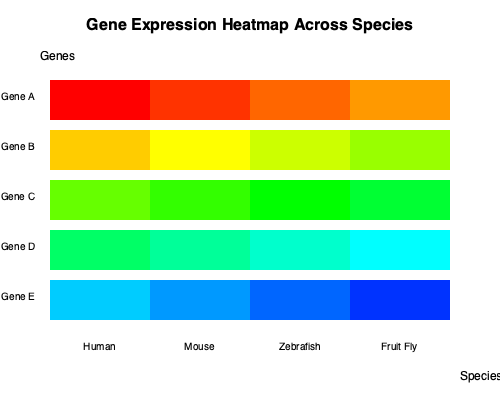Based on the gene expression heatmap across different species, which gene shows the highest degree of conservation in expression levels, and what does this suggest about its evolutionary importance? To determine the gene with the highest degree of conservation in expression levels, we need to analyze the heatmap row by row:

1. Gene A: Shows a gradient from red (high expression) in humans to orange (moderate expression) in fruit flies. This indicates variable expression across species.

2. Gene B: Displays yellow to light green colors across all species, suggesting relatively consistent moderate expression levels.

3. Gene C: Exhibits a consistent green color across all species, indicating highly conserved expression levels.

4. Gene D: Shows a gradient from light green to light blue, suggesting some variation in expression across species.

5. Gene E: Displays a gradient from light blue to dark blue, indicating variable expression across species.

Gene C shows the most consistent color (green) across all species, indicating the highest degree of conservation in expression levels.

This high degree of conservation suggests that Gene C likely plays a crucial role in fundamental biological processes that are essential for the survival and proper functioning of diverse species. Genes with highly conserved expression patterns across evolutionarily distant species are often involved in core cellular functions, developmental processes, or other critical biological pathways.

The evolutionary importance of Gene C can be inferred from this conservation:

1. Essential function: It likely performs a function that is vital for the organism's survival or fitness.
2. Evolutionary constraint: The gene has been under strong purifying selection, maintaining its expression level over millions of years of evolution.
3. Functional relevance: Its consistent expression across species suggests that its function is relevant in various biological contexts and body plans.
4. Potential model organism relevance: The conservation implies that studying this gene in model organisms like zebrafish or fruit flies could provide insights applicable to humans.
Answer: Gene C; highly conserved expression suggests crucial role in fundamental biological processes across species. 